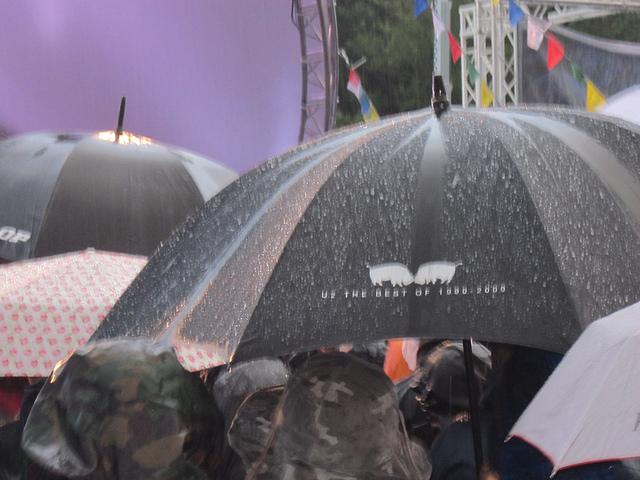Is it raining?
Be succinct. Yes. What is on the persons umbrella?
Be succinct. Bulls. What color is the large umbrella?
Concise answer only. Black. 